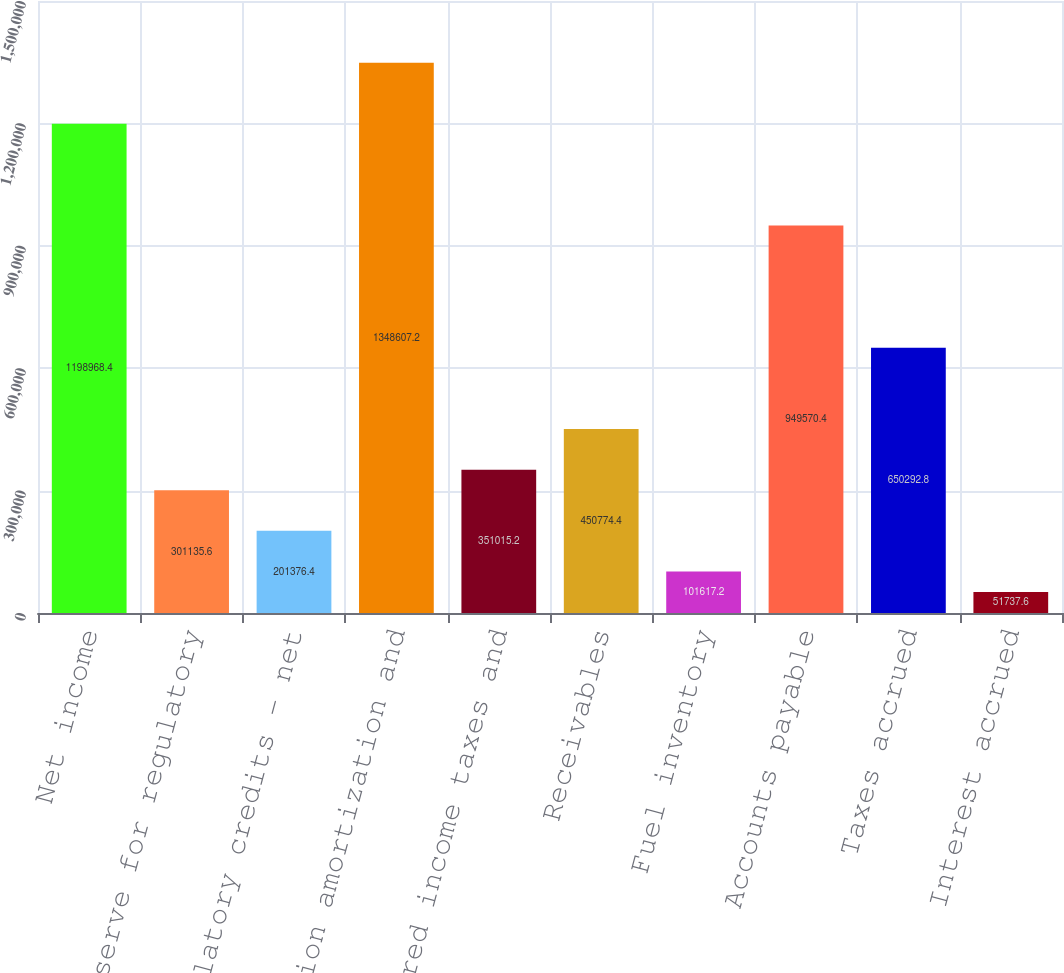<chart> <loc_0><loc_0><loc_500><loc_500><bar_chart><fcel>Net income<fcel>Reserve for regulatory<fcel>Other regulatory credits - net<fcel>Depreciation amortization and<fcel>Deferred income taxes and<fcel>Receivables<fcel>Fuel inventory<fcel>Accounts payable<fcel>Taxes accrued<fcel>Interest accrued<nl><fcel>1.19897e+06<fcel>301136<fcel>201376<fcel>1.34861e+06<fcel>351015<fcel>450774<fcel>101617<fcel>949570<fcel>650293<fcel>51737.6<nl></chart> 